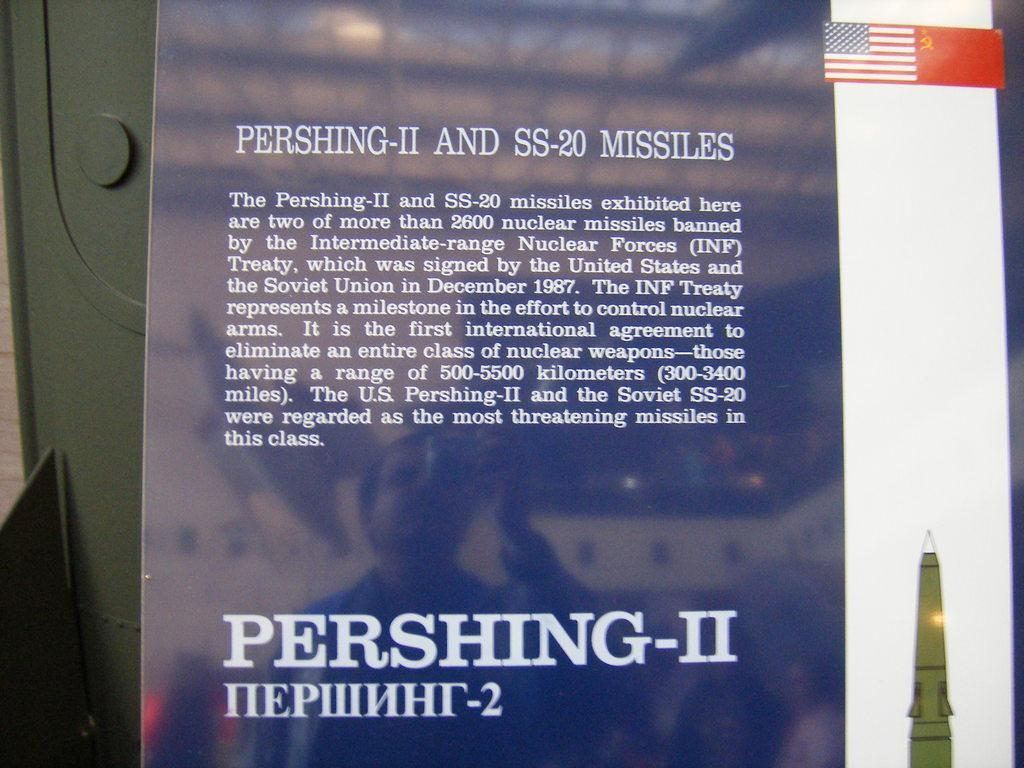<image>
Present a compact description of the photo's key features. A plaque describes the Pershing-II and SS-20 Missiles 